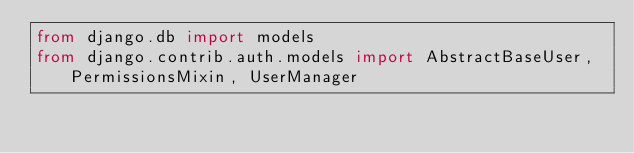<code> <loc_0><loc_0><loc_500><loc_500><_Python_>from django.db import models
from django.contrib.auth.models import AbstractBaseUser, PermissionsMixin, UserManager</code> 